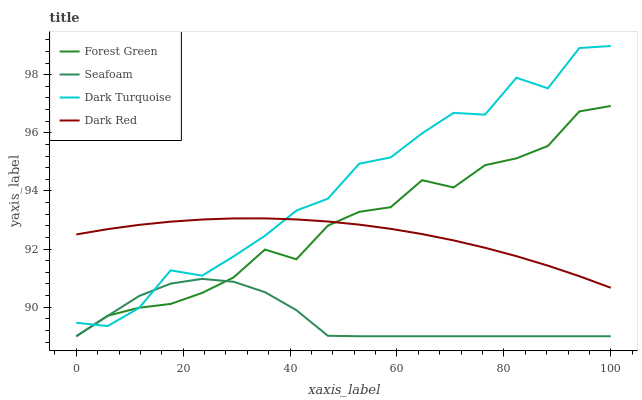Does Seafoam have the minimum area under the curve?
Answer yes or no. Yes. Does Dark Turquoise have the maximum area under the curve?
Answer yes or no. Yes. Does Forest Green have the minimum area under the curve?
Answer yes or no. No. Does Forest Green have the maximum area under the curve?
Answer yes or no. No. Is Dark Red the smoothest?
Answer yes or no. Yes. Is Dark Turquoise the roughest?
Answer yes or no. Yes. Is Forest Green the smoothest?
Answer yes or no. No. Is Forest Green the roughest?
Answer yes or no. No. Does Dark Red have the lowest value?
Answer yes or no. No. Does Dark Turquoise have the highest value?
Answer yes or no. Yes. Does Forest Green have the highest value?
Answer yes or no. No. Is Seafoam less than Dark Red?
Answer yes or no. Yes. Is Dark Red greater than Seafoam?
Answer yes or no. Yes. Does Dark Red intersect Forest Green?
Answer yes or no. Yes. Is Dark Red less than Forest Green?
Answer yes or no. No. Is Dark Red greater than Forest Green?
Answer yes or no. No. Does Seafoam intersect Dark Red?
Answer yes or no. No. 